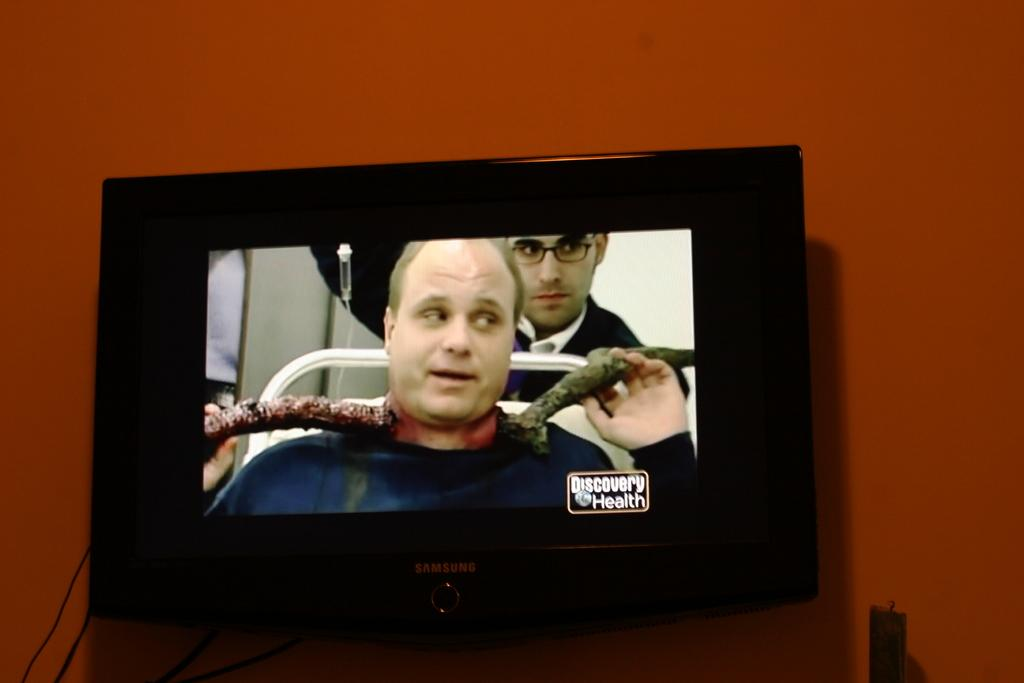<image>
Provide a brief description of the given image. a man that is on discovery health tv 